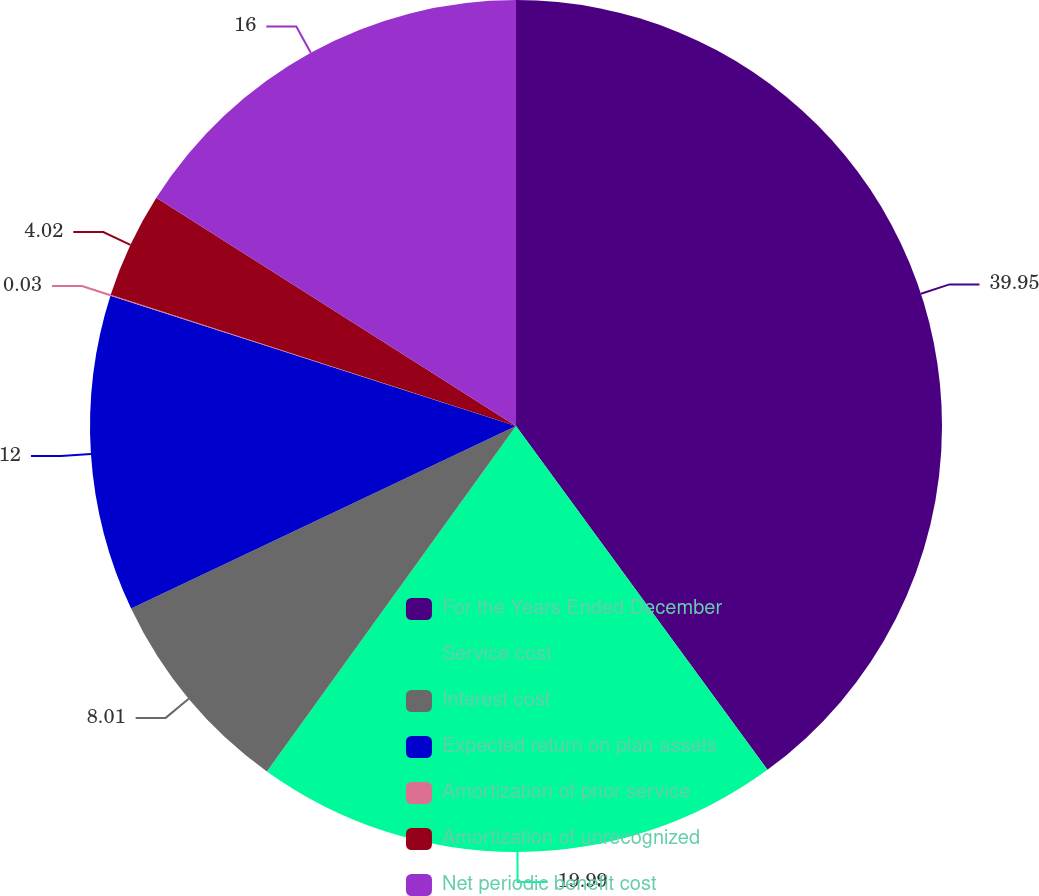<chart> <loc_0><loc_0><loc_500><loc_500><pie_chart><fcel>For the Years Ended December<fcel>Service cost<fcel>Interest cost<fcel>Expected return on plan assets<fcel>Amortization of prior service<fcel>Amortization of unrecognized<fcel>Net periodic benefit cost<nl><fcel>39.95%<fcel>19.99%<fcel>8.01%<fcel>12.0%<fcel>0.03%<fcel>4.02%<fcel>16.0%<nl></chart> 